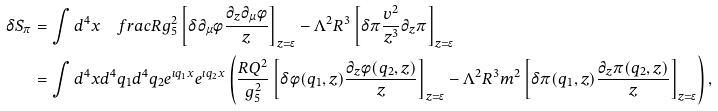Convert formula to latex. <formula><loc_0><loc_0><loc_500><loc_500>\delta S _ { \pi } & = \int d ^ { 4 } x \quad f r a c { R } { g _ { 5 } ^ { 2 } } \left [ \delta \partial _ { \mu } \phi \frac { \partial _ { z } \partial _ { \mu } \phi } { z } \right ] _ { z = \epsilon } - \Lambda ^ { 2 } R ^ { 3 } \left [ \delta \pi \frac { v ^ { 2 } } { z ^ { 3 } } \partial _ { z } \pi \right ] _ { z = \epsilon } \\ & = \int d ^ { 4 } x d ^ { 4 } q _ { 1 } d ^ { 4 } q _ { 2 } e ^ { \imath q _ { 1 } x } e ^ { \imath q _ { 2 } x } \left ( \frac { R Q ^ { 2 } } { g _ { 5 } ^ { 2 } } \left [ \delta \phi ( q _ { 1 } , z ) \frac { \partial _ { z } \phi ( q _ { 2 } , z ) } { z } \right ] _ { z = \epsilon } - \Lambda ^ { 2 } R ^ { 3 } m ^ { 2 } \left [ \delta \pi ( q _ { 1 } , z ) \frac { \partial _ { z } \pi ( q _ { 2 } , z ) } { z } \right ] _ { z = \epsilon } \right ) ,</formula> 